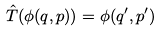<formula> <loc_0><loc_0><loc_500><loc_500>\hat { T } ( \phi ( q , p ) ) = \phi ( q ^ { \prime } , p ^ { \prime } )</formula> 